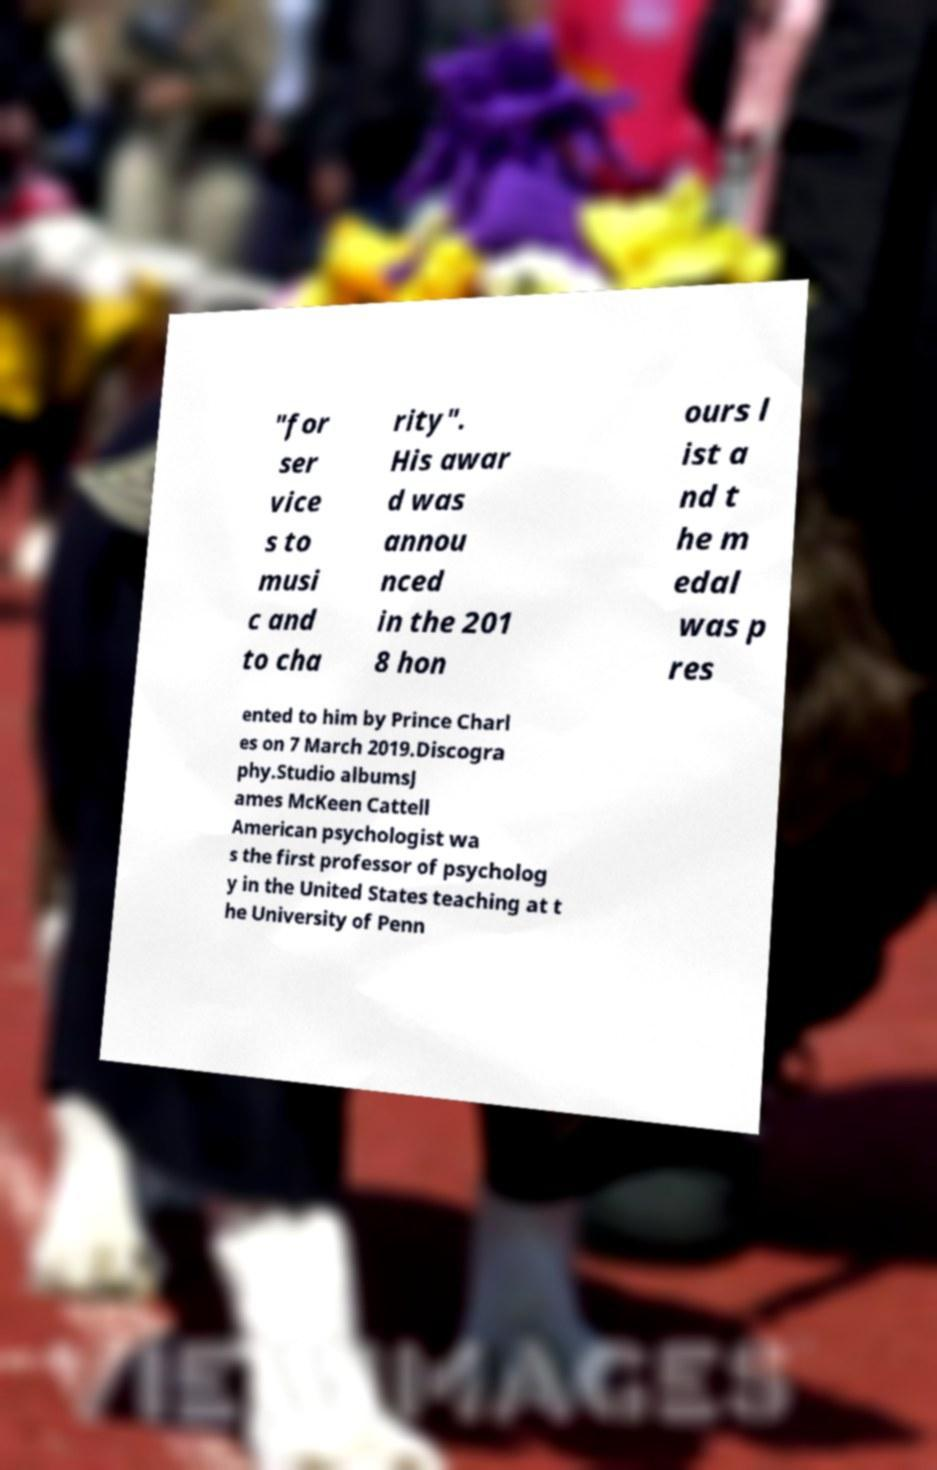I need the written content from this picture converted into text. Can you do that? "for ser vice s to musi c and to cha rity". His awar d was annou nced in the 201 8 hon ours l ist a nd t he m edal was p res ented to him by Prince Charl es on 7 March 2019.Discogra phy.Studio albumsJ ames McKeen Cattell American psychologist wa s the first professor of psycholog y in the United States teaching at t he University of Penn 